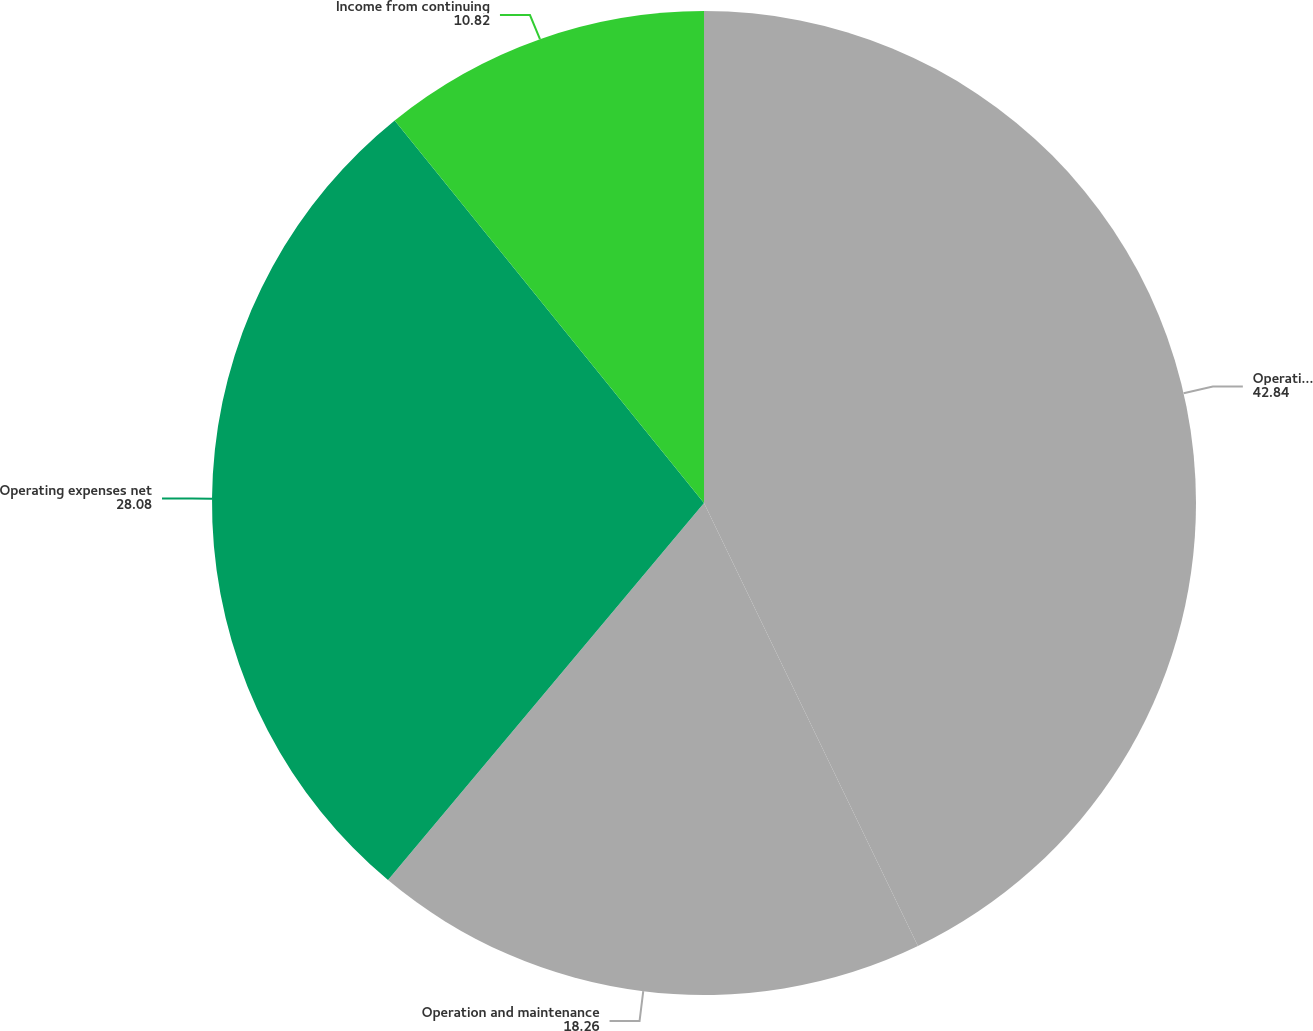<chart> <loc_0><loc_0><loc_500><loc_500><pie_chart><fcel>Operating revenues<fcel>Operation and maintenance<fcel>Operating expenses net<fcel>Income from continuing<nl><fcel>42.84%<fcel>18.26%<fcel>28.08%<fcel>10.82%<nl></chart> 